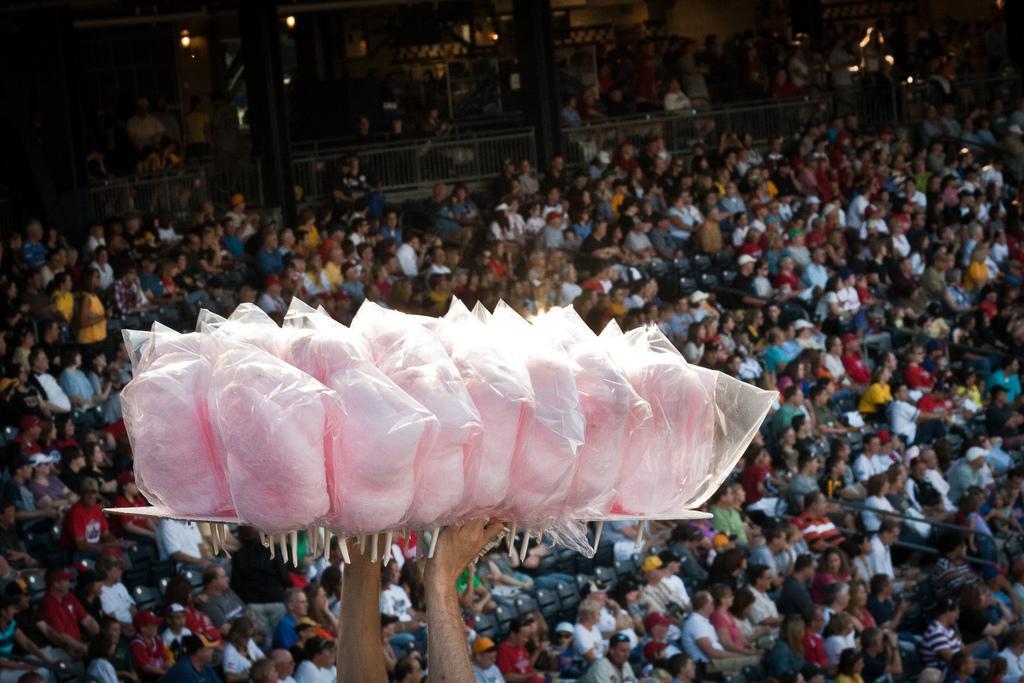Please provide a concise description of this image. In this image I can see a group of people sitting on the chairs. Back l can see pillars,fencing,lights and wall. In front I can see a person is holding few pink candy. 